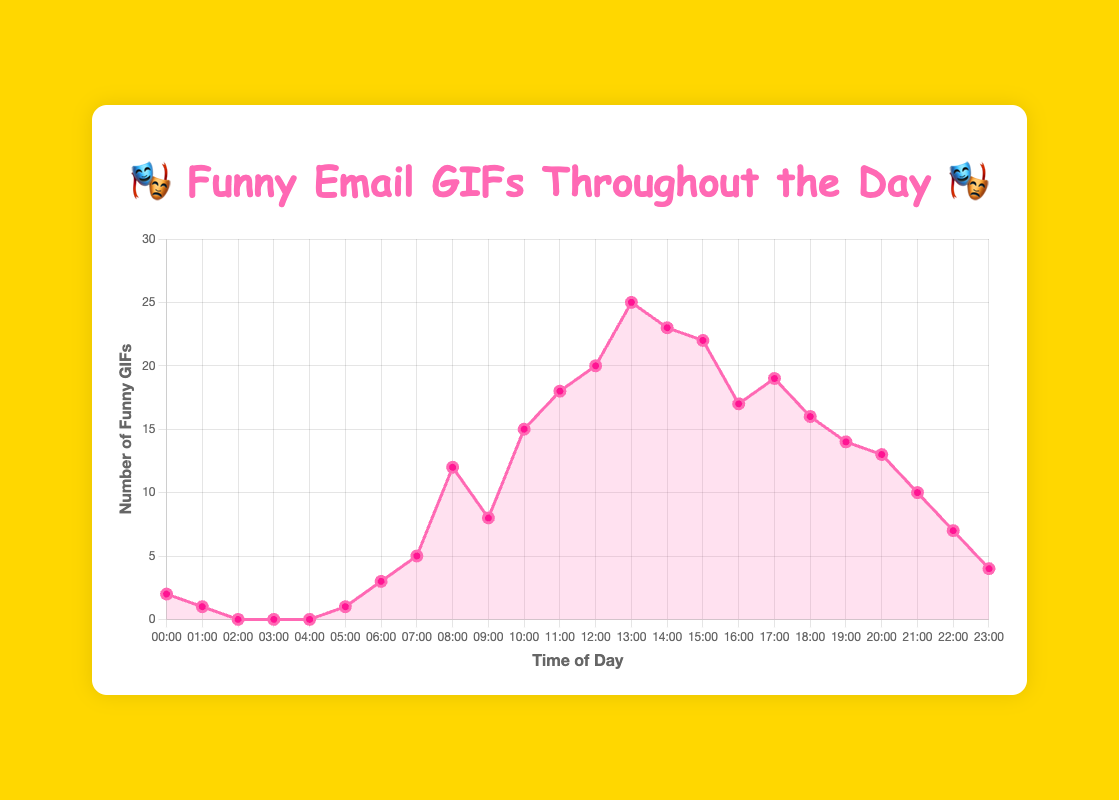What time of day had the highest number of funny GIFs sent? We look at the chart and identify the peak in the line, which happens at "13:00". The number of funny GIFs sent at that time is the highest at 25.
Answer: 13:00 During which hour is the decrease in the number of funny GIFs the greatest? The greatest decrease can be observed between "13:00" and "16:00", where the number of GIFs goes from 25 down to 17, a decrease of 8.
Answer: Between 13:00 and 16:00 How many funny GIFs were sent in total before noon? We sum up the number of funny GIFs from "00:00" to "11:00". (2 + 1 + 0 + 0 + 0 + 1 + 3 + 5 + 12 + 8 + 15 + 18) = 65
Answer: 65 Which time of the day has more funny GIFs: "08:00" or "17:00"? The number of funny GIFs sent at "08:00" is 12, and at "17:00" is 19. Comparing these, we see that "17:00" has more GIFs.
Answer: 17:00 What is the average number of funny GIFs sent between "10:00" and "14:00"? We calculate the average by summing the numbers from "10:00" to "14:00" and dividing by the count of those hours. (15 + 18 + 20 + 25 + 23) / 5 = 101 / 5 = 20.2
Answer: 20.2 Identify the consistent trend in the number of funny GIFs sent from "06:00" to "12:00". Observing the chart, we see a steady upward trend from "06:00" (3 GIFs) to "12:00" (20 GIFs), showing an increase in the number of GIFs sent.
Answer: Upward Trend Which hour marks the beginning of a noticeable increase in the number of funny GIFs sent? From "05:00" to "06:00", the line starts rising from 1 to 3, marking the beginning of a noticeable increase which continues sharply after "07:00".
Answer: 06:00 How many more funny GIFs are sent at "19:00" compared to "04:00"? The number of GIFs at "19:00" is 14 and at "04:00" is 0. The difference is 14 - 0 = 14 GIFs.
Answer: 14 What is the median number of funny GIFs sent across the entire day? To find the median, we need to sort the number of GIFs and find the middle value. The sorted list is: 0, 0, 0, 0, 1, 1, 2, 3, 4, 5, 7, 8, 10, 12, 13, 14, 15, 16, 17, 18, 19, 20, 22, 23, 25. There are 24 values, so the median is the average of the 12th and 13th values: (10 + 12) / 2 = 11
Answer: 11 